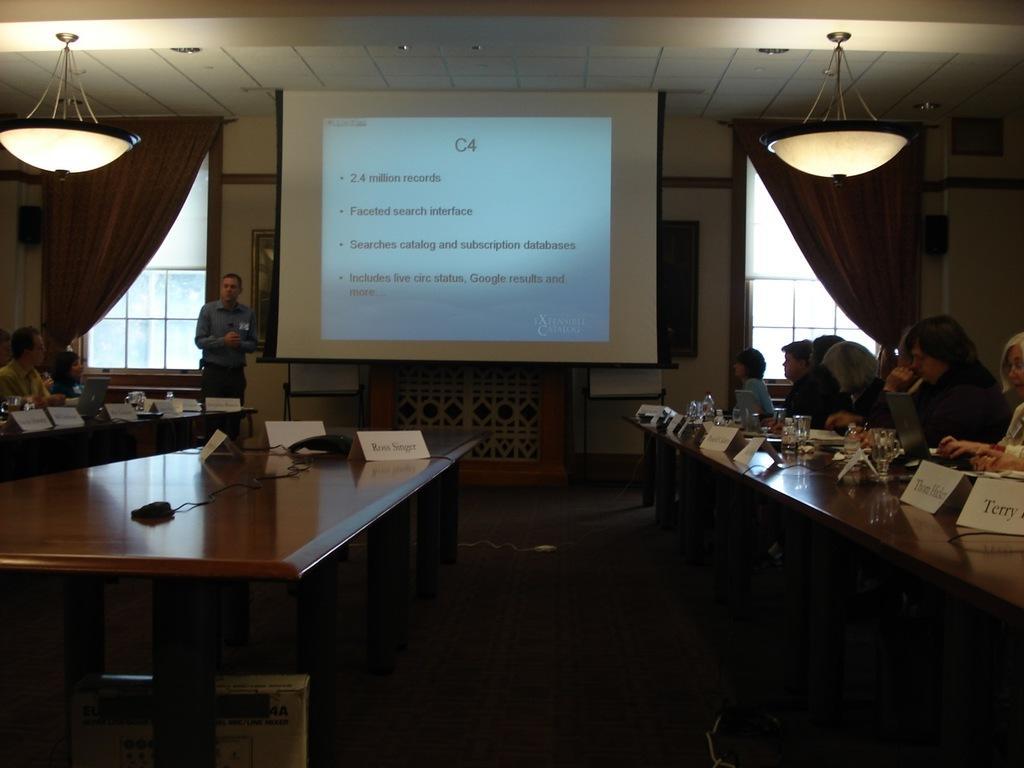Can you describe this image briefly? In the middle of the image there is a screen. Beside the screen there is a man standing. Bottom left side of the image there is a table. Left side of the image there is a man and a woman sitting on the chair and there is a window and there is a curtain. At the top the image there is a roof and lights. Bottom right side of the image there is a table, On the table there are some glasses and there is a laptop and few people are sitting on the chair. 